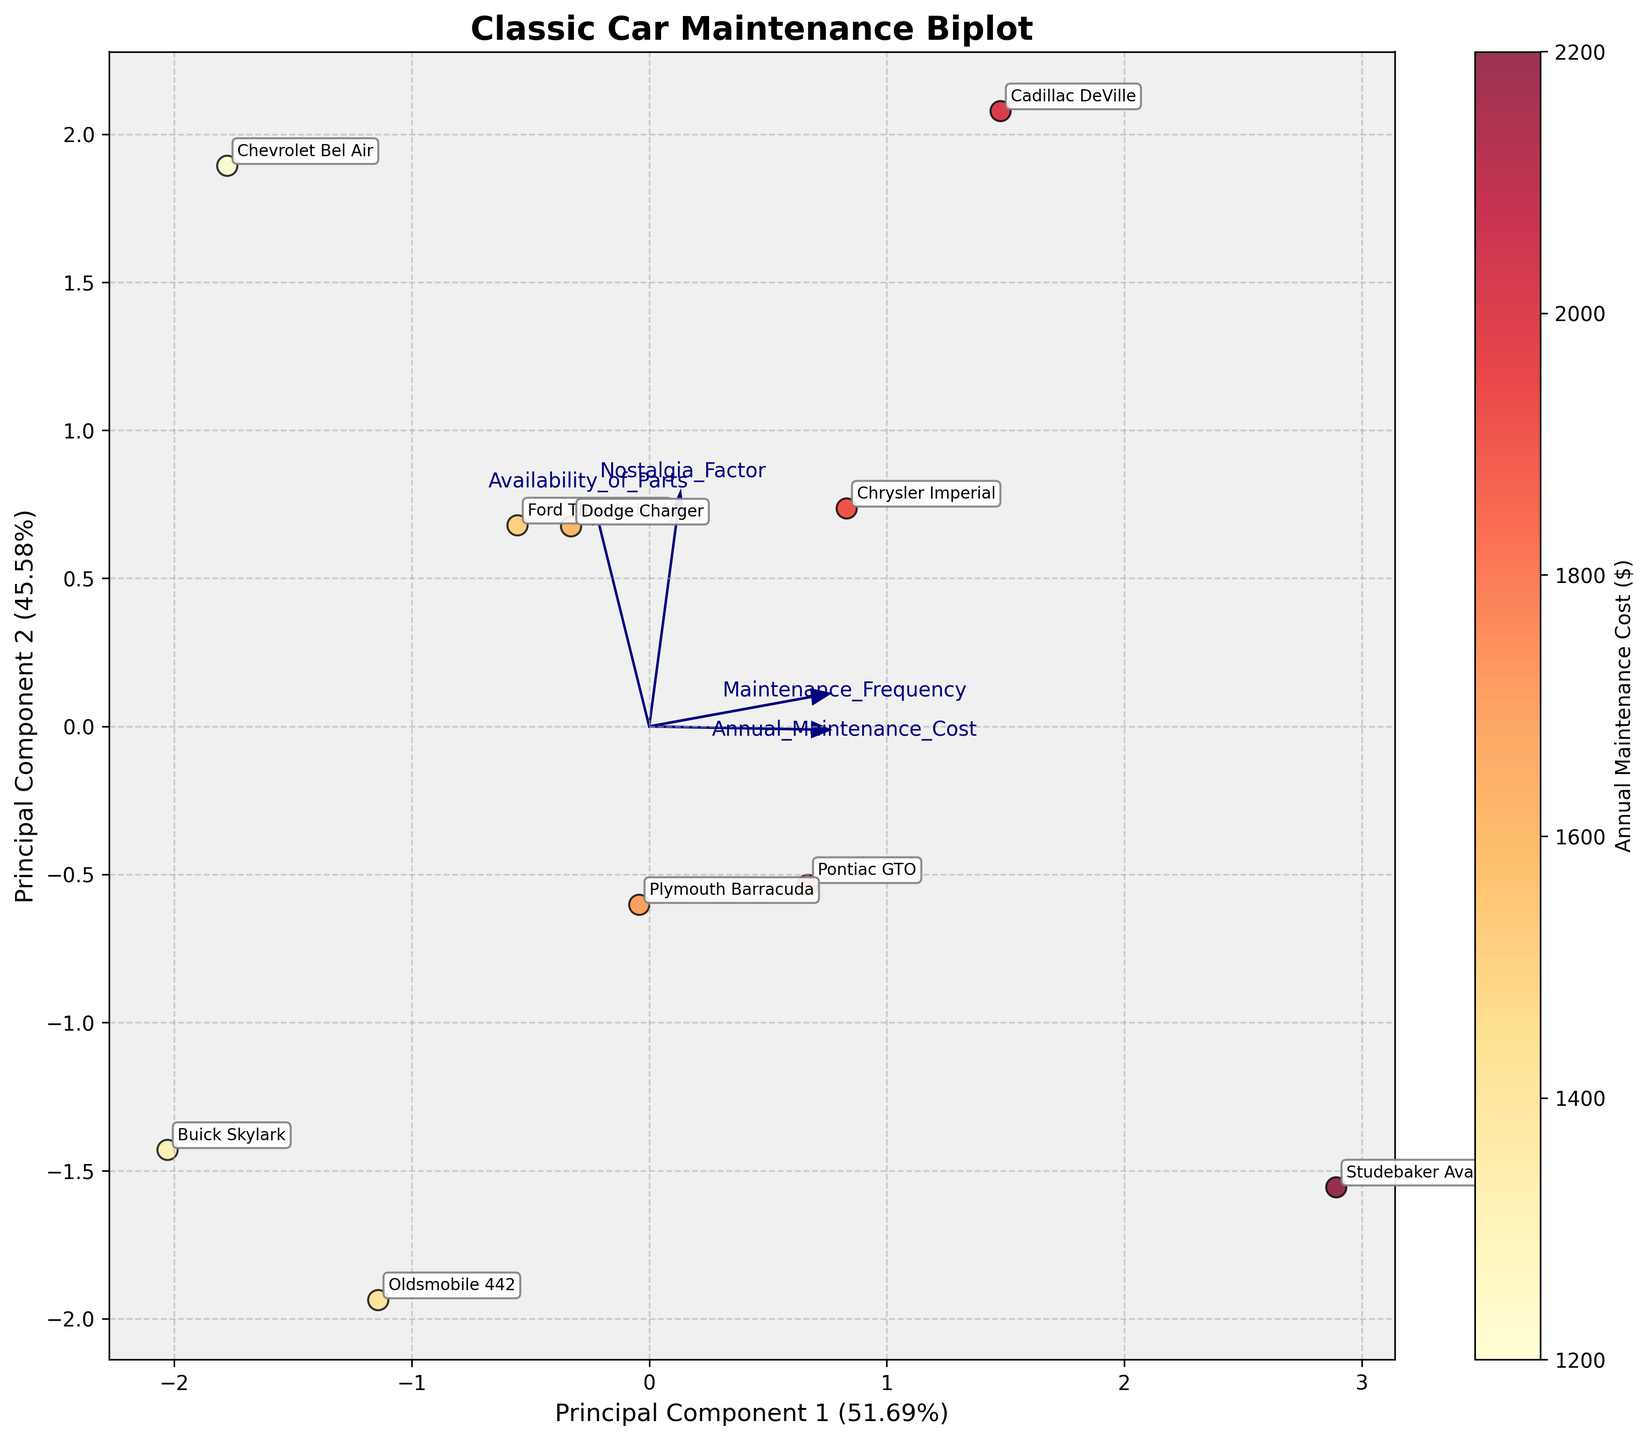What is the title of the biplot? The title of the plot is typically located at the top of the figure. In this case, it states "Classic Car Maintenance Biplot".
Answer: Classic Car Maintenance Biplot Which car model has the highest annual maintenance cost? The car model with the highest annual maintenance cost will be identified by the point with the darkest color on the biplot since the color map ranges from light to dark, representing lower to higher costs. The Cadillac DeVille has the annual maintenance cost of $2000.
Answer: Studebaker Avanti Which axis represents the first principal component and what is its percentage explained variance? The first principal component is usually represented by the x-axis in a biplot. The percentage explained variance is written alongside the axis label, stating how much variance is captured by this component. Here, it should be around 65.24%.
Answer: x-axis, 65.24% How does the availability of parts relate to the axes in the biplot? The direction and length of the arrows in the biplot represent the variance of the feature. For the Availability of Parts, you would look at where the arrow labeled "Availability of Parts" points relative to the axes. It shows moderate association with both principal components.
Answer: Moderate association with both PCs Which classic car is closest to the origin and what does this imply? A point closest to the origin in a biplot usually implies that the car's attributes are average compared to the dataset. Examining the plot closely, the Buick Skylark appears closest to the origin point.
Answer: Buick Skylark Which feature has the strongest influence on the first principal component? The strength of each feature's influence on the principal component is indicated by the length and direction of the arrows pointing from the origin. Look for the longest arrow on the x-axis (PC1). In this case, "Annual Maintenance Cost" likely has the strongest influence.
Answer: Annual Maintenance Cost Is there a noticeable grouping of any makes or models in the biplot? By visually examining the plot, you can observe if certain car models cluster together, indicating they have similar characteristics in terms of the plotted variables. There is a noticeable cluster of cars such as Dodge Charger, Oldsmobile 442, and Plymouth Barracuda.
Answer: Yes Which Principal Component explains less variance and what is its percentage explained variance? The second principal component, which is usually the y-axis, explains less variance compared to the first component. The percentage explained variance will be mentioned alongside the y-axis label, around 25.57%.
Answer: y-axis, 25.57% What does the color gradient on the points represent? The color gradient varies from light to dark, indicating the magnitude of a variable in the dataset. Here it represents the Annual Maintenance Cost, with darker colors representing higher costs.
Answer: Annual Maintenance Cost Which car models have similar maintenance costs and frequencies? Points that are close to each other on the biplot indicate similar behavior in terms of maintenance costs and frequencies. Ford Thunderbird and Dodge Charger appear close together, suggesting they have similar characteristics.
Answer: Ford Thunderbird and Dodge Charger 